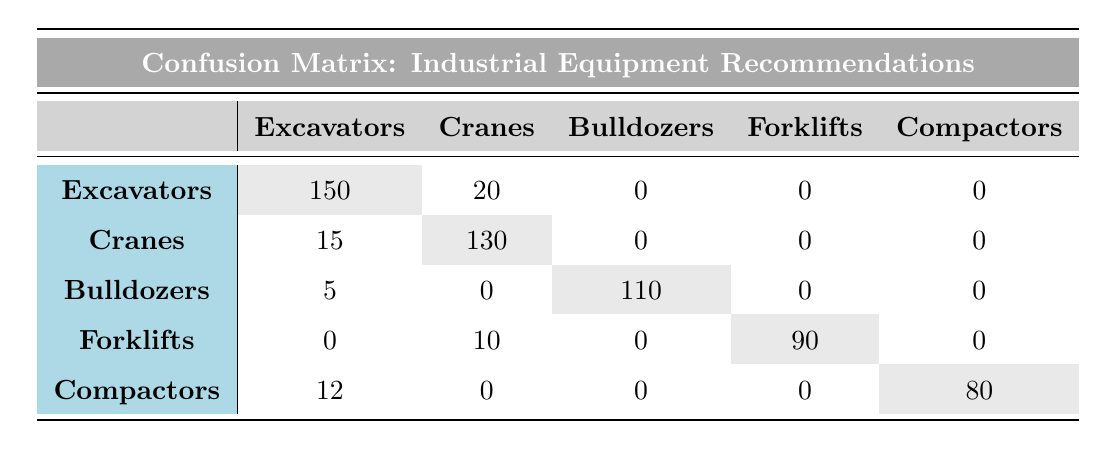What is the predicted category for the largest number of actual Excavators? The table shows that for actual Excavators, the predicted category is Excavators with a count of 150.
Answer: Excavators How many times were Cranes incorrectly predicted as Excavators? The table indicates that Cranes were predicted as Excavators 15 times.
Answer: 15 What is the total number of Bulldozers predicted correctly? The table shows there were 110 correct predictions for Bulldozers.
Answer: 110 Which category had the least number of correct predictions? Upon reviewing the table, Forklifts had the least correct predictions at 90.
Answer: Forklifts Are there any incorrect predictions for Compactors? The table indicates Compactors were predicted incorrectly as Excavators 12 times, which means there were incorrect predictions.
Answer: Yes What is the difference between correct predictions for Excavators and Compactors? Excavators had 150 correct predictions, while Compactors had 80 correct predictions. Therefore, the difference is 150 - 80 = 70.
Answer: 70 How many products were predicted as Cranes in total (both correctly and incorrectly)? The table lists 130 correctly predicted as Cranes and 20 incorrectly predicted as Excavators, resulting in a total of 130 + 20 = 150.
Answer: 150 What percentage of total predictions does the correct prediction for Bulldozers represent? The total predictions can be calculated as (150 + 20 + 130 + 15 + 110 + 5 + 90 + 10 + 80 + 12) = 602. The correct predictions for Bulldozers are 110, so the percentage is (110/602) * 100 ≈ 18.26%.
Answer: Approximately 18.26% Which category had the most total recommendations (correct plus incorrect)? By totaling each category, Excavators (150 + 20) = 170, Cranes (15 + 130) = 145, Bulldozers (5 + 110) = 115, Forklifts (10 + 90) = 100, Compactors (12 + 80) = 92. Therefore, Excavators had the most recommendations at 170.
Answer: Excavators 